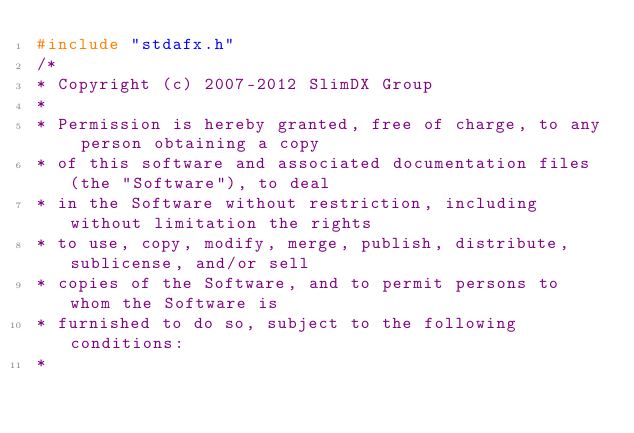<code> <loc_0><loc_0><loc_500><loc_500><_C++_>#include "stdafx.h"
/*
* Copyright (c) 2007-2012 SlimDX Group
* 
* Permission is hereby granted, free of charge, to any person obtaining a copy
* of this software and associated documentation files (the "Software"), to deal
* in the Software without restriction, including without limitation the rights
* to use, copy, modify, merge, publish, distribute, sublicense, and/or sell
* copies of the Software, and to permit persons to whom the Software is
* furnished to do so, subject to the following conditions:
* </code> 